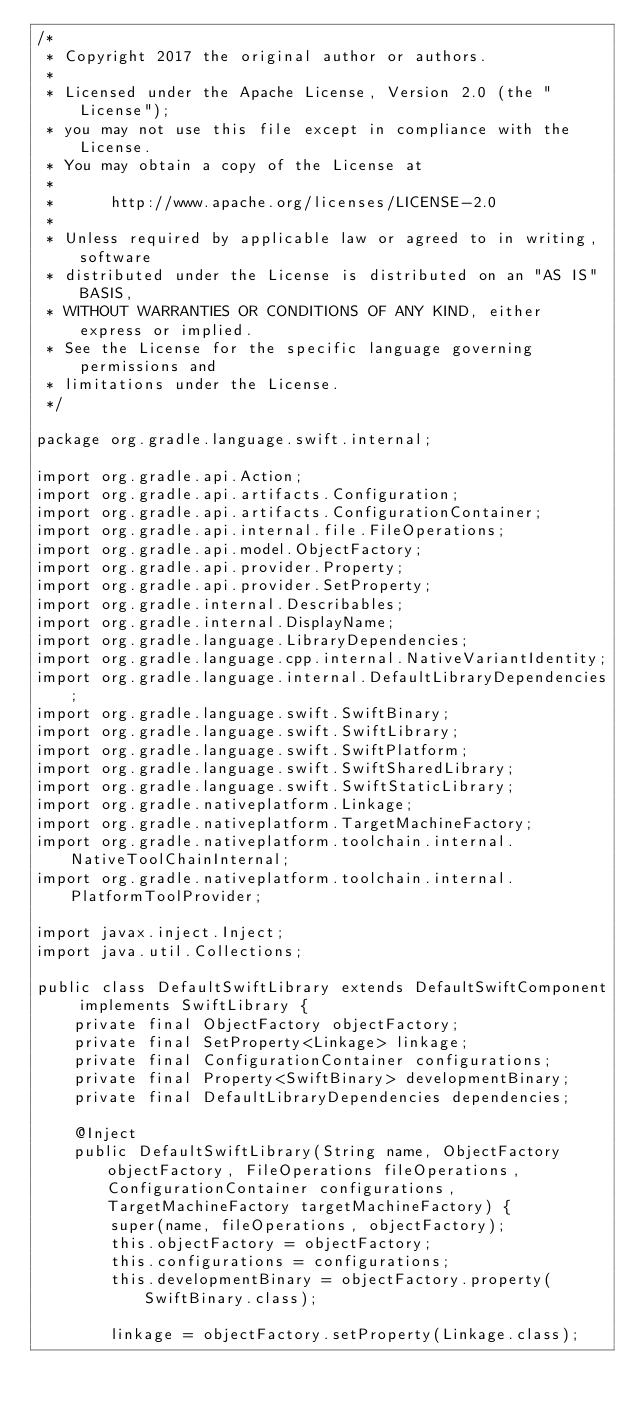<code> <loc_0><loc_0><loc_500><loc_500><_Java_>/*
 * Copyright 2017 the original author or authors.
 *
 * Licensed under the Apache License, Version 2.0 (the "License");
 * you may not use this file except in compliance with the License.
 * You may obtain a copy of the License at
 *
 *      http://www.apache.org/licenses/LICENSE-2.0
 *
 * Unless required by applicable law or agreed to in writing, software
 * distributed under the License is distributed on an "AS IS" BASIS,
 * WITHOUT WARRANTIES OR CONDITIONS OF ANY KIND, either express or implied.
 * See the License for the specific language governing permissions and
 * limitations under the License.
 */

package org.gradle.language.swift.internal;

import org.gradle.api.Action;
import org.gradle.api.artifacts.Configuration;
import org.gradle.api.artifacts.ConfigurationContainer;
import org.gradle.api.internal.file.FileOperations;
import org.gradle.api.model.ObjectFactory;
import org.gradle.api.provider.Property;
import org.gradle.api.provider.SetProperty;
import org.gradle.internal.Describables;
import org.gradle.internal.DisplayName;
import org.gradle.language.LibraryDependencies;
import org.gradle.language.cpp.internal.NativeVariantIdentity;
import org.gradle.language.internal.DefaultLibraryDependencies;
import org.gradle.language.swift.SwiftBinary;
import org.gradle.language.swift.SwiftLibrary;
import org.gradle.language.swift.SwiftPlatform;
import org.gradle.language.swift.SwiftSharedLibrary;
import org.gradle.language.swift.SwiftStaticLibrary;
import org.gradle.nativeplatform.Linkage;
import org.gradle.nativeplatform.TargetMachineFactory;
import org.gradle.nativeplatform.toolchain.internal.NativeToolChainInternal;
import org.gradle.nativeplatform.toolchain.internal.PlatformToolProvider;

import javax.inject.Inject;
import java.util.Collections;

public class DefaultSwiftLibrary extends DefaultSwiftComponent implements SwiftLibrary {
    private final ObjectFactory objectFactory;
    private final SetProperty<Linkage> linkage;
    private final ConfigurationContainer configurations;
    private final Property<SwiftBinary> developmentBinary;
    private final DefaultLibraryDependencies dependencies;

    @Inject
    public DefaultSwiftLibrary(String name, ObjectFactory objectFactory, FileOperations fileOperations, ConfigurationContainer configurations, TargetMachineFactory targetMachineFactory) {
        super(name, fileOperations, objectFactory);
        this.objectFactory = objectFactory;
        this.configurations = configurations;
        this.developmentBinary = objectFactory.property(SwiftBinary.class);

        linkage = objectFactory.setProperty(Linkage.class);</code> 